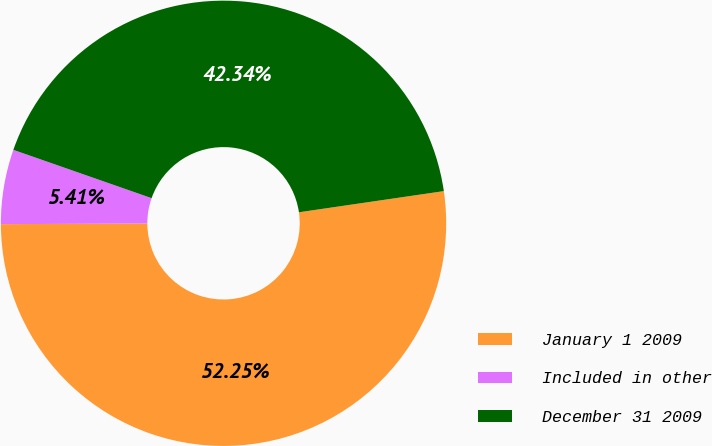<chart> <loc_0><loc_0><loc_500><loc_500><pie_chart><fcel>January 1 2009<fcel>Included in other<fcel>December 31 2009<nl><fcel>52.25%<fcel>5.41%<fcel>42.34%<nl></chart> 